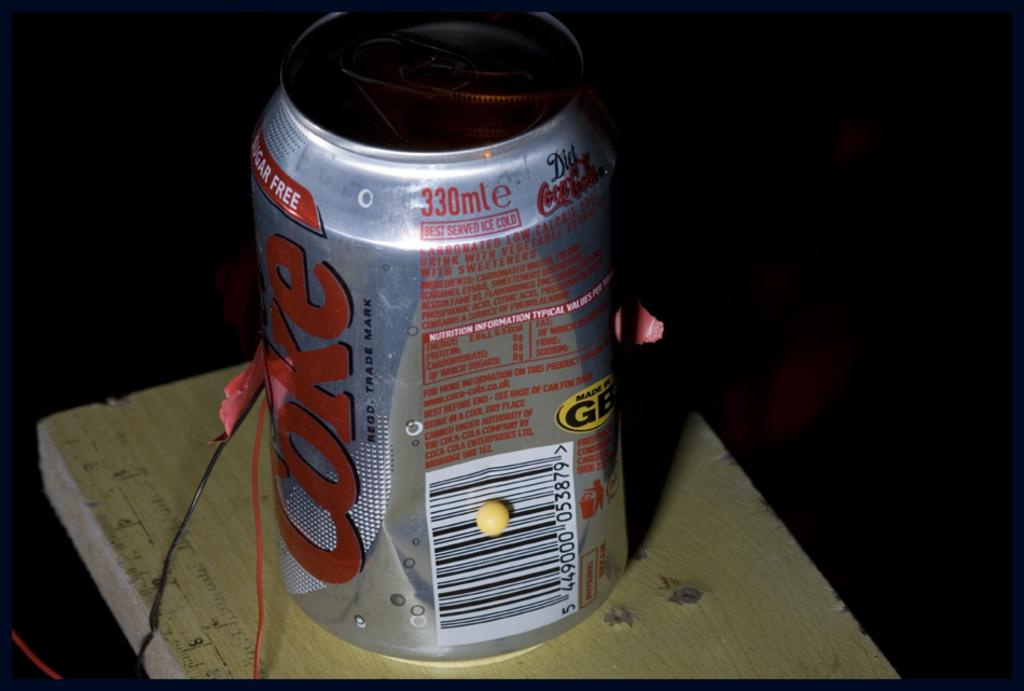<image>
Provide a brief description of the given image. A dented diet coke can with some wires around it. 